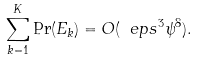<formula> <loc_0><loc_0><loc_500><loc_500>\sum _ { k = 1 } ^ { K } \Pr ( E _ { k } ) = O ( \ e p s ^ { 3 } \psi ^ { 8 } ) .</formula> 